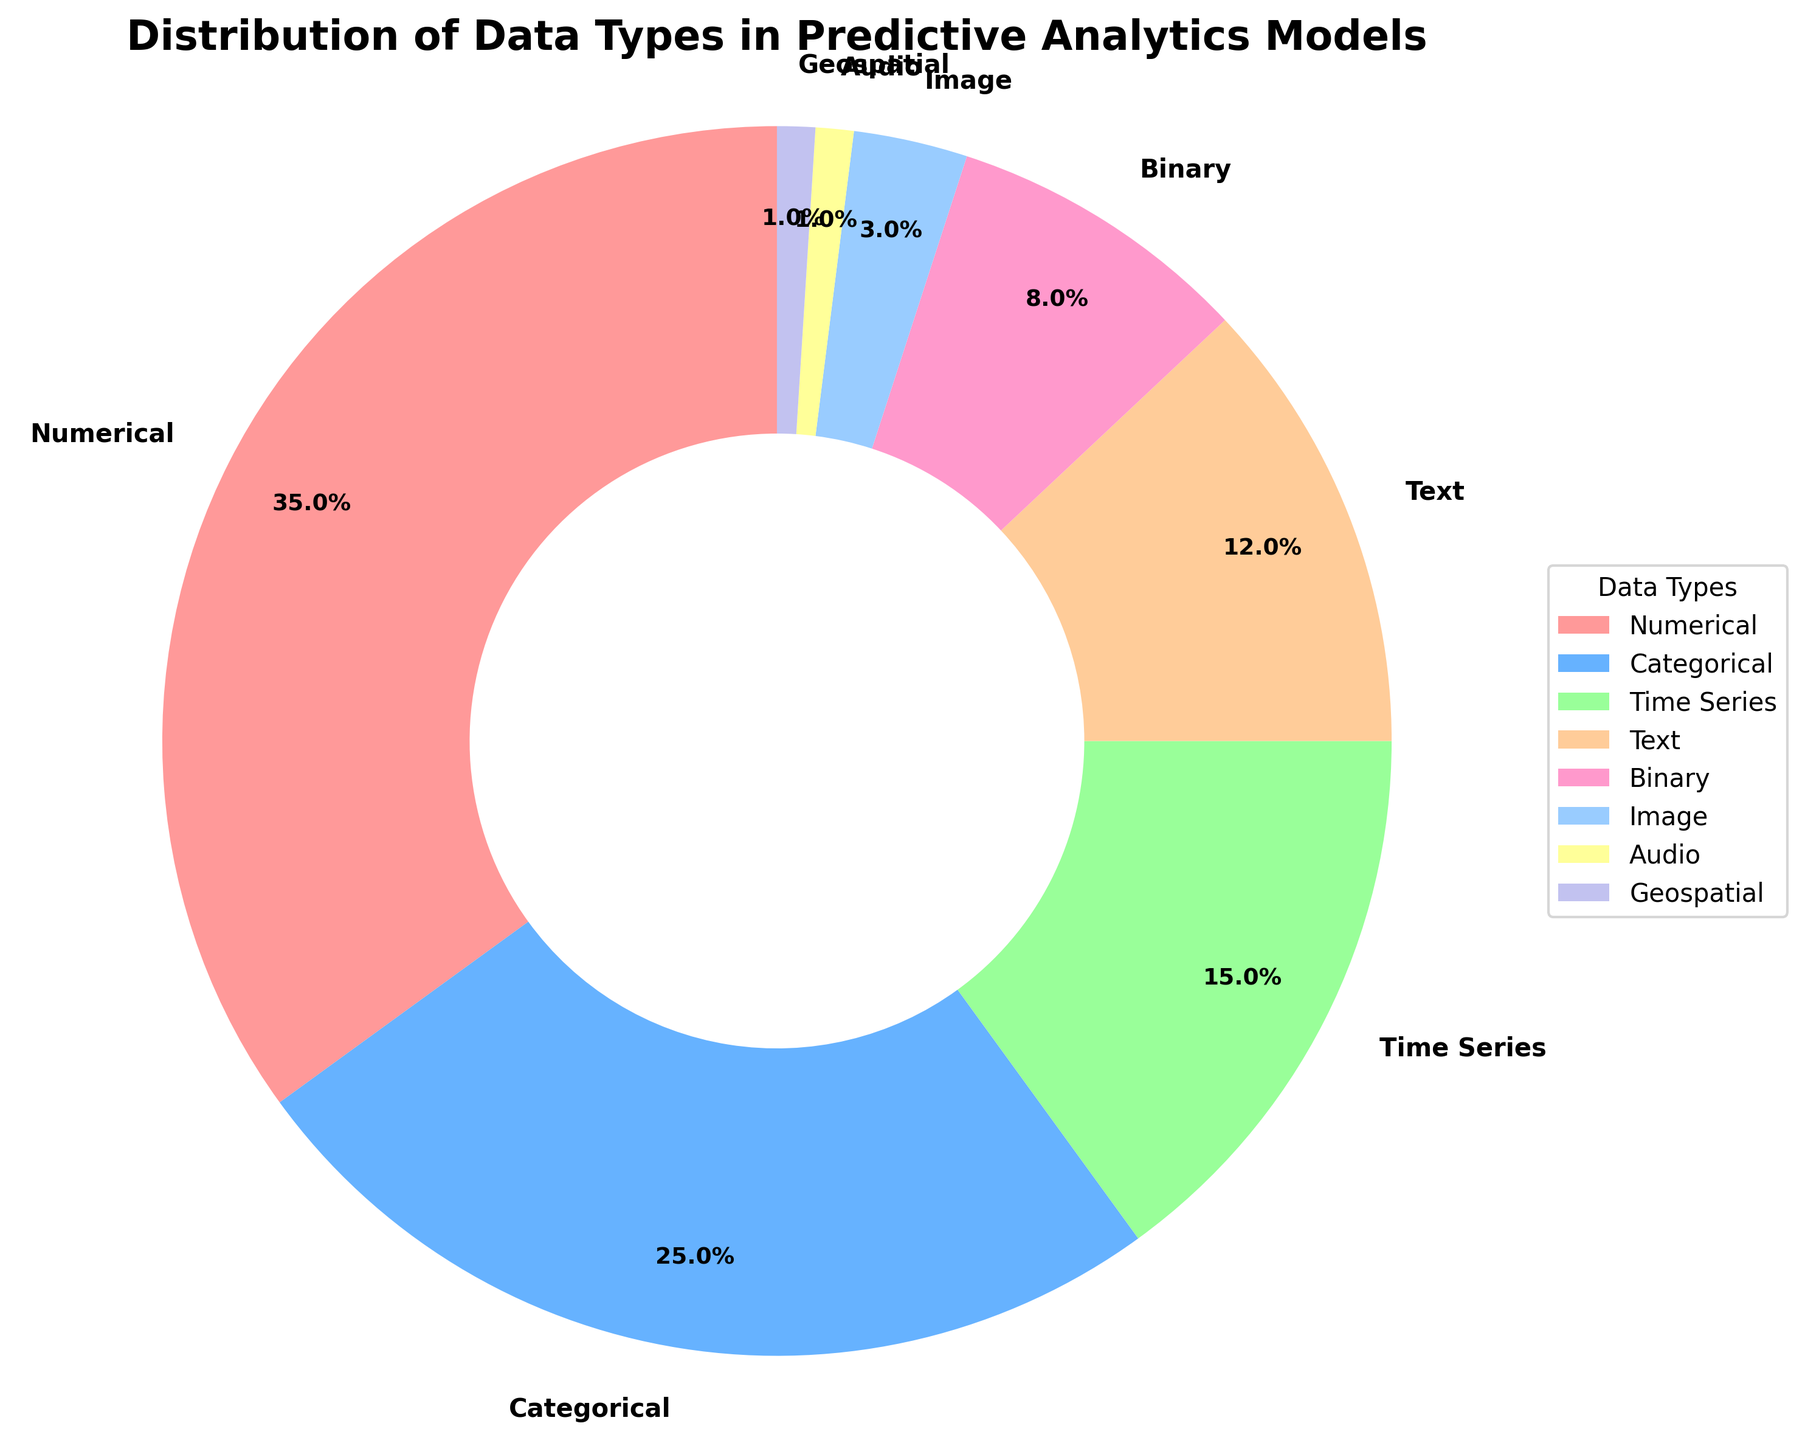Which data type has the highest percentage in the pie chart? The largest wedge in the pie chart represents Numerical data, which has the highest percentage, indicated as 35% on the chart.
Answer: Numerical What is the combined percentage of Categorical, Time Series, and Text data types? Categorical is 25%, Time Series is 15%, and Text is 12%. Adding these together, 25 + 15 + 12 = 52%.
Answer: 52% What's the difference in percentage between Numerical and Categorical data types? Numerical is 35% and Categorical is 25%. The difference is 35 - 25 = 10%.
Answer: 10% Which three data types have the smallest wedges in the pie chart? The chart shows that Audio, Geospatial, and Image data types have the smallest percentages, which are 1%, 1%, and 3% respectively.
Answer: Audio, Geospatial, Image Is the percentage of Binary data greater than the percentage of Text data? The pie chart shows that Binary data is 8% and Text data is 12%. Since 8% is less than 12%, Binary data is not greater than Text data.
Answer: No What is the average percentage of Numerical, Binary, and Image data types? Numerical is 35%, Binary is 8%, and Image is 3%. The average is (35 + 8 + 3) / 3 = 46 / 3 ≈ 15.33%.
Answer: 15.33% What color is used to represent Categorical data in the pie chart? The pie chart shows Categorical data in a blue slice, specifically the second slice from the start angle.
Answer: Blue Which data type has twice the percentage of Binary data? Binary data is 8%. The data type with twice this percentage is Numerical, which is 35% (though slightly above twice).
Answer: Numerical Is the combined percentage of Image and Audio data equal to the percentage of Time Series data? Image is 3% and Audio is 1%, combined they are 3 + 1 = 4%. Time Series data is 15%. 4% is not equal to 15%.
Answer: No 